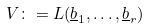Convert formula to latex. <formula><loc_0><loc_0><loc_500><loc_500>V \colon = L ( \underline { b } _ { 1 } , \dots , \underline { b } _ { r } )</formula> 